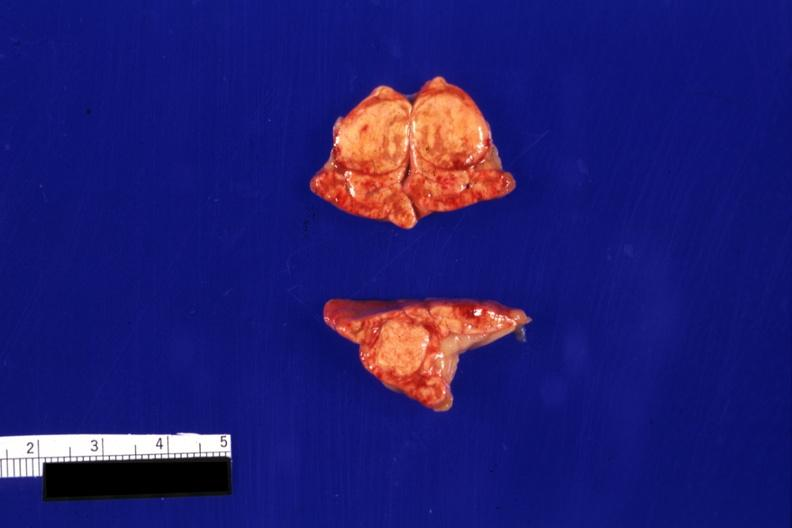s cachexia present?
Answer the question using a single word or phrase. No 